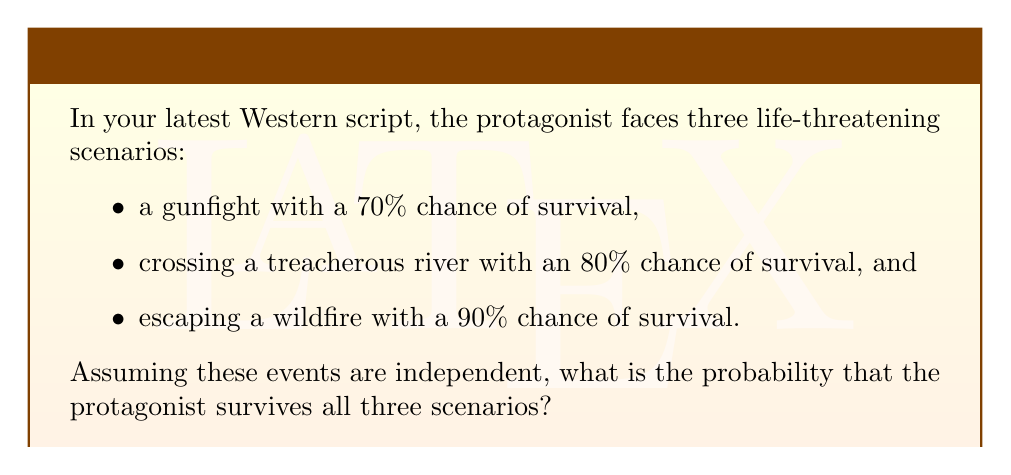Can you answer this question? To solve this problem, we need to follow these steps:

1. Identify the probability of survival for each scenario:
   - Gunfight: $P(\text{survive gunfight}) = 0.70$
   - River crossing: $P(\text{survive river}) = 0.80$
   - Wildfire escape: $P(\text{survive wildfire}) = 0.90$

2. Since we want the protagonist to survive all three scenarios, and the events are independent, we need to multiply the individual probabilities:

   $$P(\text{survive all}) = P(\text{survive gunfight}) \times P(\text{survive river}) \times P(\text{survive wildfire})$$

3. Substitute the values:

   $$P(\text{survive all}) = 0.70 \times 0.80 \times 0.90$$

4. Perform the multiplication:

   $$P(\text{survive all}) = 0.504$$

5. Convert to a percentage:

   $$P(\text{survive all}) = 0.504 \times 100\% = 50.4\%$$

Therefore, the probability that the protagonist survives all three scenarios is 50.4%.
Answer: 50.4% 